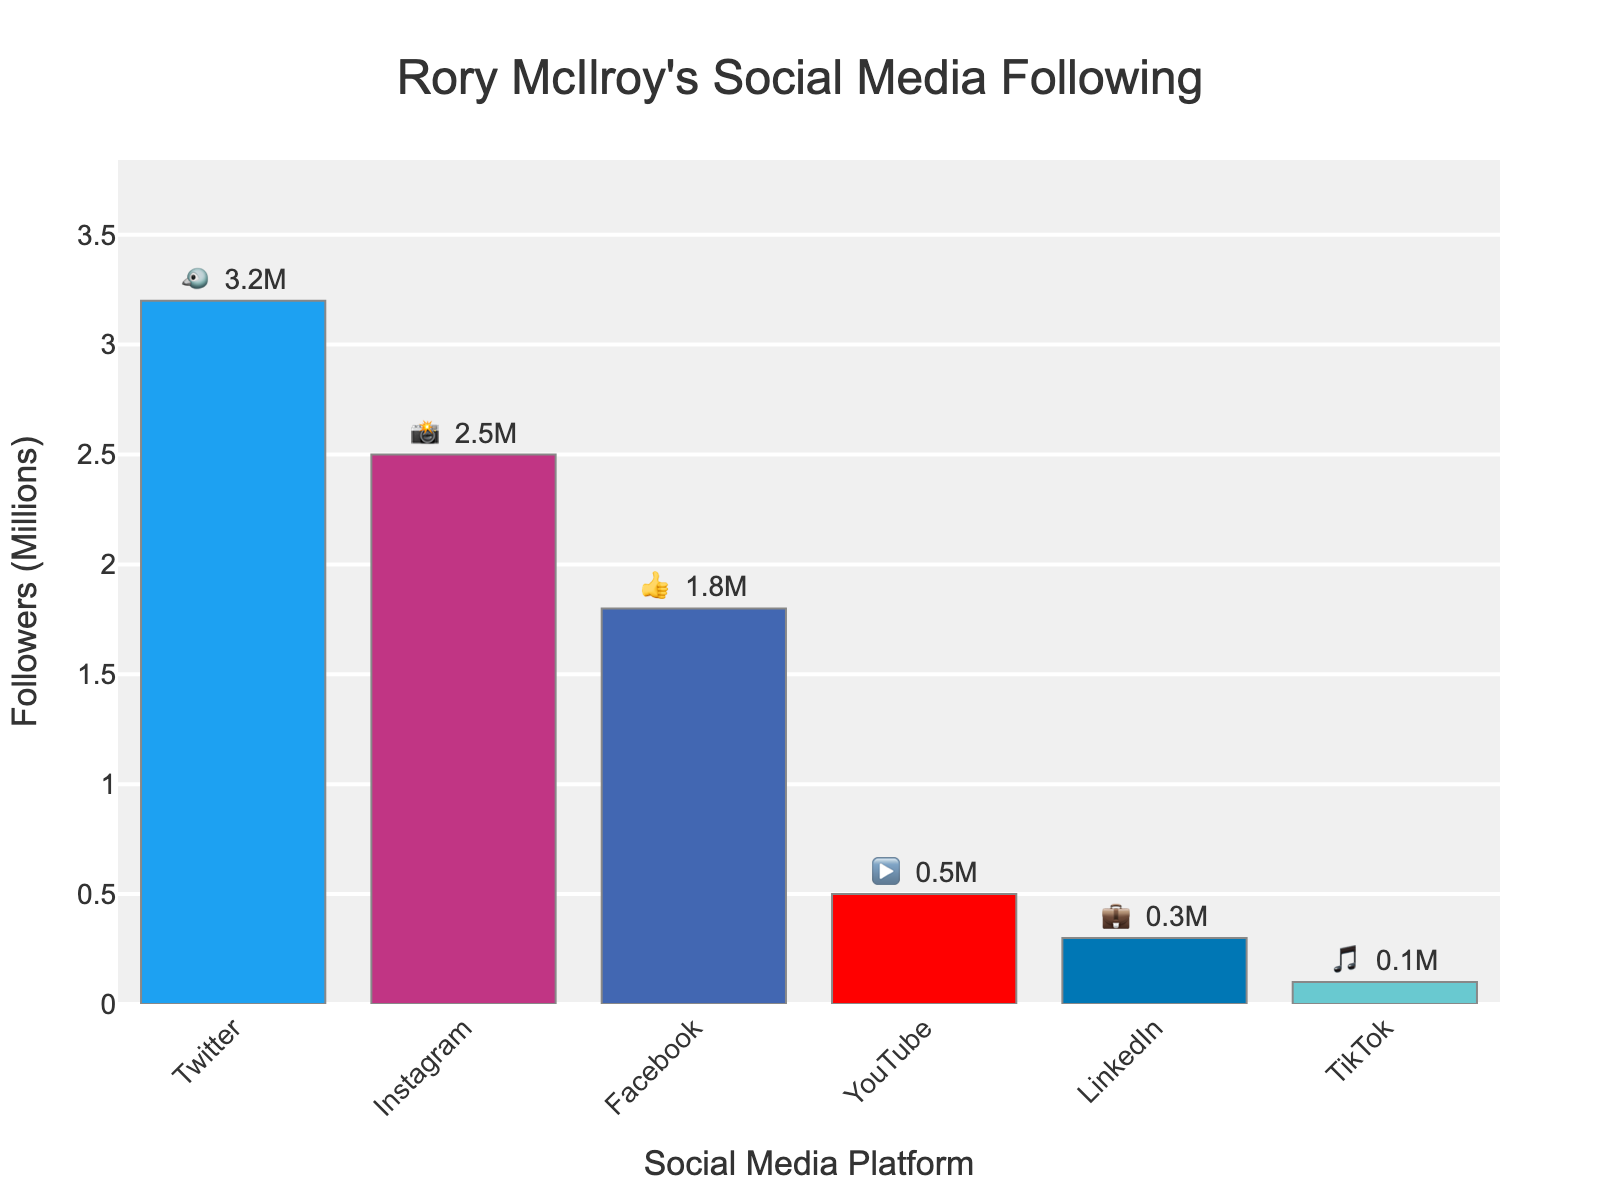What's the title of the figure? The title is prominently displayed at the top of the figure. It reads, "Rory McIlroy's Social Media Following."
Answer: Rory McIlroy's Social Media Following Which social media platform has the most followers for Rory McIlroy? By observing the number of followers and the emojis next to the bars, the platform with the longest bar represents the highest number of followers. That platform is Twitter, represented by the 🐦 emoji.
Answer: Twitter How many followers does Rory McIlroy have on Instagram? Locate the bar labeled with the Instagram emoji (📸), and read the text displaying the followers. It shows "2.5M".
Answer: 2.5 million Which platform has fewer followers, Facebook or YouTube? Compare the heights of the bars corresponding to Facebook (👍) and YouTube (▶️). YouTube's bar is shorter, indicating fewer followers.
Answer: YouTube What's the total number of followers on TikTok and LinkedIn combined? Add the number of followers for TikTok (🎵) and LinkedIn (💼) respectively. TikTok has 0.1 million, and LinkedIn has 0.3 million followers. Summing them gives 0.1M + 0.3M = 0.4M.
Answer: 0.4 million Which has more followers, Instagram or Facebook? By how much? Compare the bars for Instagram (📸) and Facebook (👍). Instagram has 2.5M followers, while Facebook has 1.8M followers. The difference is 2.5M - 1.8M = 0.7M.
Answer: Instagram by 0.7 million What is the average number of followers across all platforms? Calculate the sum of followers for all platforms (3.2M for Twitter, 2.5M for Instagram, 1.8M for Facebook, 0.5M for YouTube, 0.3M for LinkedIn, and 0.1M for TikTok). The total is 8.4 million. There are 6 platforms, so the average is 8.4M / 6 = 1.4M.
Answer: 1.4 million Which platform has the smallest number of followers, and what is that number? Look for the bar with the smallest height, corresponding to the fewest followers, which is TikTok (🎵) with 0.1 million followers.
Answer: TikTok, 0.1 million How many platforms have more than 1 million followers for Rory McIlroy? Count the number of platforms where the bars' text indicates more than 1 million followers. These platforms are Twitter, Instagram, and Facebook. Thus, there are 3 platforms.
Answer: 3 What is the difference in followers between Rory McIlroy's Twitter and YouTube accounts? Twitter has 3.2M followers, and YouTube has 0.5M followers. The difference is 3.2M - 0.5M = 2.7M.
Answer: 2.7 million 